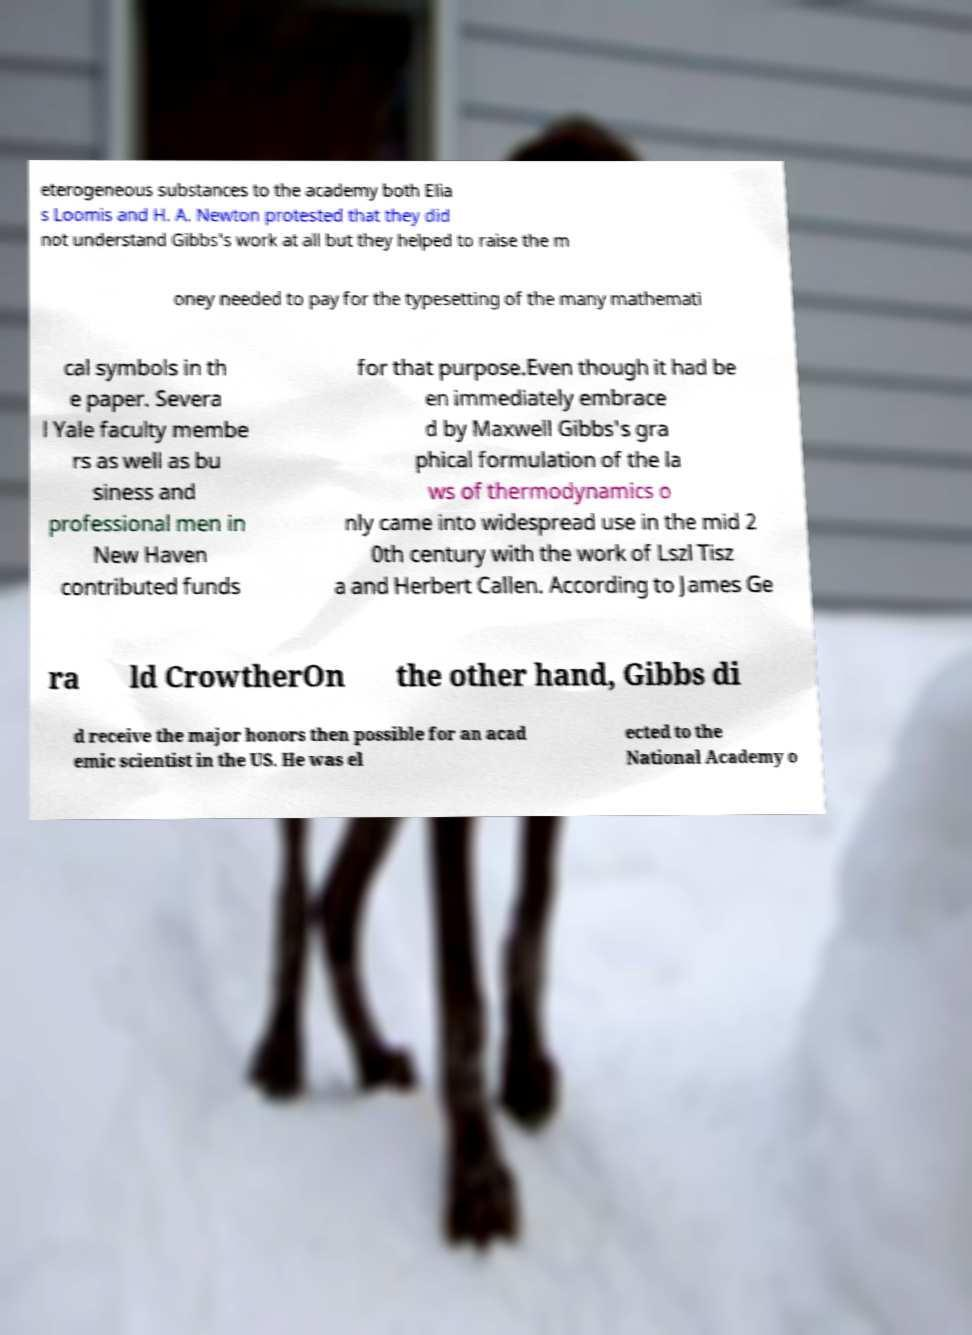Please read and relay the text visible in this image. What does it say? eterogeneous substances to the academy both Elia s Loomis and H. A. Newton protested that they did not understand Gibbs's work at all but they helped to raise the m oney needed to pay for the typesetting of the many mathemati cal symbols in th e paper. Severa l Yale faculty membe rs as well as bu siness and professional men in New Haven contributed funds for that purpose.Even though it had be en immediately embrace d by Maxwell Gibbs's gra phical formulation of the la ws of thermodynamics o nly came into widespread use in the mid 2 0th century with the work of Lszl Tisz a and Herbert Callen. According to James Ge ra ld CrowtherOn the other hand, Gibbs di d receive the major honors then possible for an acad emic scientist in the US. He was el ected to the National Academy o 